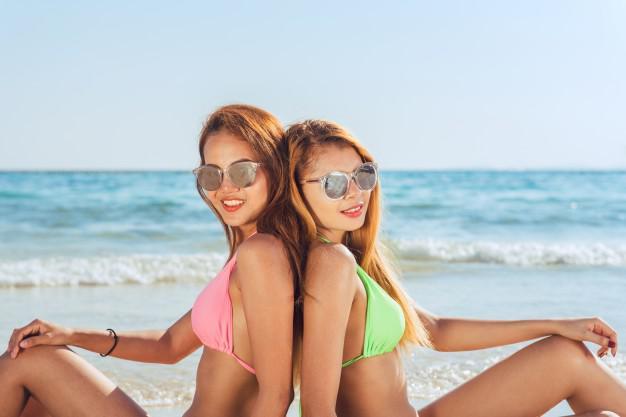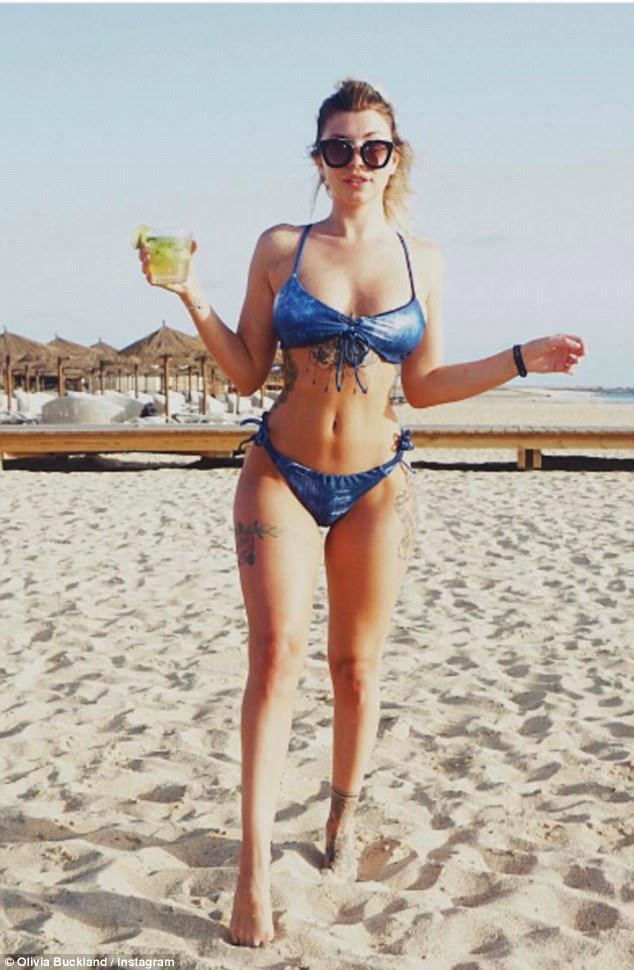The first image is the image on the left, the second image is the image on the right. Examine the images to the left and right. Is the description "In 1 of the images, 1 girl with a pink bikini and 1 girl with a green bikini is sitting." accurate? Answer yes or no. Yes. The first image is the image on the left, the second image is the image on the right. Given the left and right images, does the statement "There are three women at the beach." hold true? Answer yes or no. Yes. 